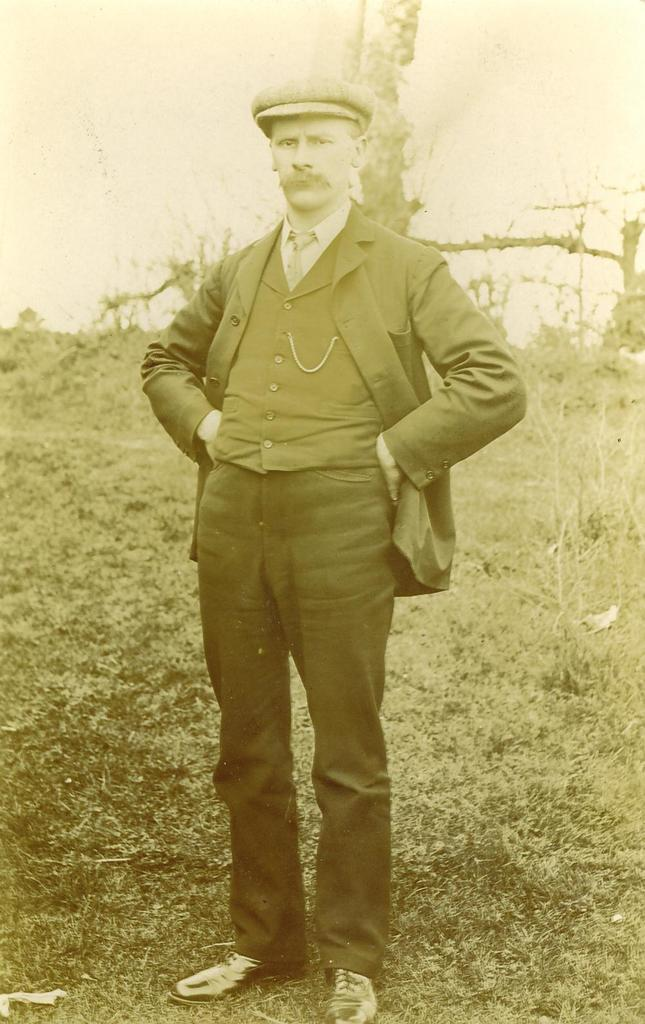What is the main subject of the image? There is a person standing in the image. Can you describe the person's attire? The person is wearing a cap. What can be seen in the background of the image? There are trees in the background of the image. What is visible at the bottom of the image? The ground is visible at the bottom of the image. What type of plant is the person holding in the image? There is no plant visible in the image; the person is only wearing a cap and standing in front of trees. 